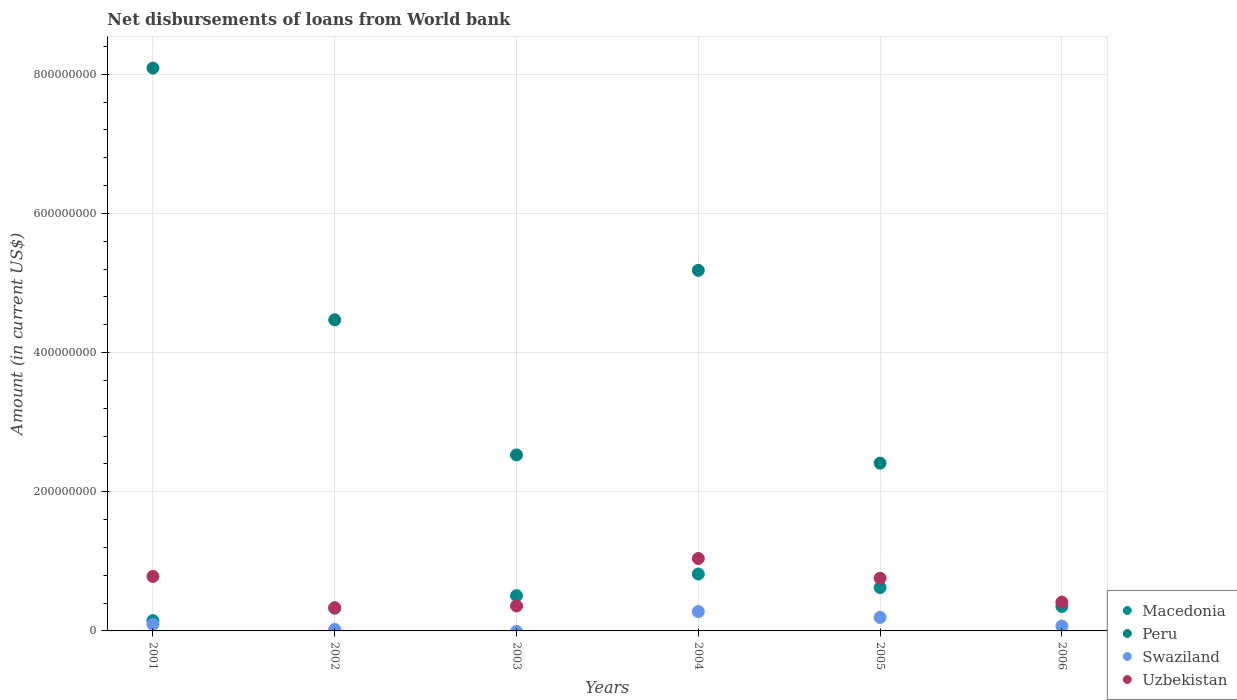How many different coloured dotlines are there?
Your answer should be very brief. 4. Is the number of dotlines equal to the number of legend labels?
Keep it short and to the point. No. What is the amount of loan disbursed from World Bank in Swaziland in 2005?
Give a very brief answer. 1.94e+07. Across all years, what is the maximum amount of loan disbursed from World Bank in Swaziland?
Ensure brevity in your answer.  2.78e+07. Across all years, what is the minimum amount of loan disbursed from World Bank in Uzbekistan?
Keep it short and to the point. 3.34e+07. What is the total amount of loan disbursed from World Bank in Peru in the graph?
Make the answer very short. 2.27e+09. What is the difference between the amount of loan disbursed from World Bank in Macedonia in 2004 and that in 2005?
Your answer should be compact. 1.94e+07. What is the difference between the amount of loan disbursed from World Bank in Uzbekistan in 2005 and the amount of loan disbursed from World Bank in Macedonia in 2001?
Your answer should be very brief. 6.09e+07. What is the average amount of loan disbursed from World Bank in Peru per year?
Your answer should be very brief. 3.78e+08. In the year 2001, what is the difference between the amount of loan disbursed from World Bank in Macedonia and amount of loan disbursed from World Bank in Uzbekistan?
Your answer should be compact. -6.35e+07. In how many years, is the amount of loan disbursed from World Bank in Uzbekistan greater than 160000000 US$?
Your answer should be very brief. 0. What is the ratio of the amount of loan disbursed from World Bank in Macedonia in 2003 to that in 2004?
Provide a succinct answer. 0.62. What is the difference between the highest and the second highest amount of loan disbursed from World Bank in Macedonia?
Your answer should be compact. 1.94e+07. What is the difference between the highest and the lowest amount of loan disbursed from World Bank in Macedonia?
Keep it short and to the point. 6.70e+07. In how many years, is the amount of loan disbursed from World Bank in Swaziland greater than the average amount of loan disbursed from World Bank in Swaziland taken over all years?
Your answer should be very brief. 2. Is the sum of the amount of loan disbursed from World Bank in Peru in 2001 and 2002 greater than the maximum amount of loan disbursed from World Bank in Macedonia across all years?
Provide a short and direct response. Yes. Is the amount of loan disbursed from World Bank in Macedonia strictly greater than the amount of loan disbursed from World Bank in Peru over the years?
Your answer should be compact. No. How many dotlines are there?
Keep it short and to the point. 4. How many years are there in the graph?
Your answer should be compact. 6. Does the graph contain any zero values?
Your answer should be very brief. Yes. Does the graph contain grids?
Ensure brevity in your answer.  Yes. Where does the legend appear in the graph?
Give a very brief answer. Bottom right. How many legend labels are there?
Provide a short and direct response. 4. How are the legend labels stacked?
Your answer should be very brief. Vertical. What is the title of the graph?
Provide a succinct answer. Net disbursements of loans from World bank. Does "Argentina" appear as one of the legend labels in the graph?
Your answer should be compact. No. What is the label or title of the X-axis?
Your answer should be very brief. Years. What is the label or title of the Y-axis?
Provide a succinct answer. Amount (in current US$). What is the Amount (in current US$) in Macedonia in 2001?
Keep it short and to the point. 1.48e+07. What is the Amount (in current US$) in Peru in 2001?
Give a very brief answer. 8.09e+08. What is the Amount (in current US$) in Swaziland in 2001?
Your answer should be very brief. 9.49e+06. What is the Amount (in current US$) of Uzbekistan in 2001?
Make the answer very short. 7.83e+07. What is the Amount (in current US$) of Macedonia in 2002?
Make the answer very short. 3.26e+07. What is the Amount (in current US$) in Peru in 2002?
Your response must be concise. 4.47e+08. What is the Amount (in current US$) in Swaziland in 2002?
Your answer should be compact. 2.17e+06. What is the Amount (in current US$) in Uzbekistan in 2002?
Your answer should be very brief. 3.34e+07. What is the Amount (in current US$) of Macedonia in 2003?
Ensure brevity in your answer.  5.07e+07. What is the Amount (in current US$) of Peru in 2003?
Give a very brief answer. 2.53e+08. What is the Amount (in current US$) of Uzbekistan in 2003?
Provide a short and direct response. 3.59e+07. What is the Amount (in current US$) in Macedonia in 2004?
Offer a very short reply. 8.18e+07. What is the Amount (in current US$) in Peru in 2004?
Provide a short and direct response. 5.18e+08. What is the Amount (in current US$) in Swaziland in 2004?
Your answer should be very brief. 2.78e+07. What is the Amount (in current US$) in Uzbekistan in 2004?
Provide a short and direct response. 1.04e+08. What is the Amount (in current US$) of Macedonia in 2005?
Your answer should be compact. 6.23e+07. What is the Amount (in current US$) in Peru in 2005?
Make the answer very short. 2.41e+08. What is the Amount (in current US$) of Swaziland in 2005?
Offer a terse response. 1.94e+07. What is the Amount (in current US$) of Uzbekistan in 2005?
Offer a very short reply. 7.57e+07. What is the Amount (in current US$) of Macedonia in 2006?
Offer a very short reply. 3.51e+07. What is the Amount (in current US$) in Swaziland in 2006?
Provide a short and direct response. 7.05e+06. What is the Amount (in current US$) in Uzbekistan in 2006?
Your answer should be compact. 4.14e+07. Across all years, what is the maximum Amount (in current US$) in Macedonia?
Provide a succinct answer. 8.18e+07. Across all years, what is the maximum Amount (in current US$) of Peru?
Offer a terse response. 8.09e+08. Across all years, what is the maximum Amount (in current US$) in Swaziland?
Make the answer very short. 2.78e+07. Across all years, what is the maximum Amount (in current US$) of Uzbekistan?
Make the answer very short. 1.04e+08. Across all years, what is the minimum Amount (in current US$) in Macedonia?
Provide a succinct answer. 1.48e+07. Across all years, what is the minimum Amount (in current US$) in Swaziland?
Offer a very short reply. 0. Across all years, what is the minimum Amount (in current US$) in Uzbekistan?
Ensure brevity in your answer.  3.34e+07. What is the total Amount (in current US$) in Macedonia in the graph?
Provide a succinct answer. 2.77e+08. What is the total Amount (in current US$) of Peru in the graph?
Your answer should be compact. 2.27e+09. What is the total Amount (in current US$) in Swaziland in the graph?
Your answer should be very brief. 6.59e+07. What is the total Amount (in current US$) in Uzbekistan in the graph?
Your answer should be very brief. 3.69e+08. What is the difference between the Amount (in current US$) of Macedonia in 2001 and that in 2002?
Offer a terse response. -1.78e+07. What is the difference between the Amount (in current US$) in Peru in 2001 and that in 2002?
Ensure brevity in your answer.  3.62e+08. What is the difference between the Amount (in current US$) in Swaziland in 2001 and that in 2002?
Make the answer very short. 7.32e+06. What is the difference between the Amount (in current US$) of Uzbekistan in 2001 and that in 2002?
Ensure brevity in your answer.  4.49e+07. What is the difference between the Amount (in current US$) of Macedonia in 2001 and that in 2003?
Provide a short and direct response. -3.60e+07. What is the difference between the Amount (in current US$) of Peru in 2001 and that in 2003?
Your answer should be very brief. 5.56e+08. What is the difference between the Amount (in current US$) of Uzbekistan in 2001 and that in 2003?
Your answer should be very brief. 4.24e+07. What is the difference between the Amount (in current US$) in Macedonia in 2001 and that in 2004?
Your response must be concise. -6.70e+07. What is the difference between the Amount (in current US$) of Peru in 2001 and that in 2004?
Provide a short and direct response. 2.91e+08. What is the difference between the Amount (in current US$) of Swaziland in 2001 and that in 2004?
Provide a short and direct response. -1.83e+07. What is the difference between the Amount (in current US$) of Uzbekistan in 2001 and that in 2004?
Keep it short and to the point. -2.58e+07. What is the difference between the Amount (in current US$) of Macedonia in 2001 and that in 2005?
Provide a short and direct response. -4.75e+07. What is the difference between the Amount (in current US$) of Peru in 2001 and that in 2005?
Your answer should be compact. 5.68e+08. What is the difference between the Amount (in current US$) of Swaziland in 2001 and that in 2005?
Your answer should be compact. -9.90e+06. What is the difference between the Amount (in current US$) in Uzbekistan in 2001 and that in 2005?
Make the answer very short. 2.62e+06. What is the difference between the Amount (in current US$) in Macedonia in 2001 and that in 2006?
Your answer should be very brief. -2.03e+07. What is the difference between the Amount (in current US$) of Swaziland in 2001 and that in 2006?
Provide a short and direct response. 2.45e+06. What is the difference between the Amount (in current US$) in Uzbekistan in 2001 and that in 2006?
Your response must be concise. 3.69e+07. What is the difference between the Amount (in current US$) in Macedonia in 2002 and that in 2003?
Make the answer very short. -1.82e+07. What is the difference between the Amount (in current US$) of Peru in 2002 and that in 2003?
Keep it short and to the point. 1.94e+08. What is the difference between the Amount (in current US$) of Uzbekistan in 2002 and that in 2003?
Give a very brief answer. -2.46e+06. What is the difference between the Amount (in current US$) in Macedonia in 2002 and that in 2004?
Your answer should be very brief. -4.92e+07. What is the difference between the Amount (in current US$) of Peru in 2002 and that in 2004?
Ensure brevity in your answer.  -7.11e+07. What is the difference between the Amount (in current US$) in Swaziland in 2002 and that in 2004?
Provide a short and direct response. -2.56e+07. What is the difference between the Amount (in current US$) of Uzbekistan in 2002 and that in 2004?
Keep it short and to the point. -7.07e+07. What is the difference between the Amount (in current US$) of Macedonia in 2002 and that in 2005?
Keep it short and to the point. -2.97e+07. What is the difference between the Amount (in current US$) of Peru in 2002 and that in 2005?
Your response must be concise. 2.06e+08. What is the difference between the Amount (in current US$) in Swaziland in 2002 and that in 2005?
Offer a terse response. -1.72e+07. What is the difference between the Amount (in current US$) of Uzbekistan in 2002 and that in 2005?
Make the answer very short. -4.23e+07. What is the difference between the Amount (in current US$) in Macedonia in 2002 and that in 2006?
Your response must be concise. -2.47e+06. What is the difference between the Amount (in current US$) of Swaziland in 2002 and that in 2006?
Ensure brevity in your answer.  -4.88e+06. What is the difference between the Amount (in current US$) in Uzbekistan in 2002 and that in 2006?
Offer a very short reply. -7.96e+06. What is the difference between the Amount (in current US$) in Macedonia in 2003 and that in 2004?
Give a very brief answer. -3.10e+07. What is the difference between the Amount (in current US$) of Peru in 2003 and that in 2004?
Offer a terse response. -2.65e+08. What is the difference between the Amount (in current US$) of Uzbekistan in 2003 and that in 2004?
Your answer should be compact. -6.82e+07. What is the difference between the Amount (in current US$) of Macedonia in 2003 and that in 2005?
Your answer should be very brief. -1.16e+07. What is the difference between the Amount (in current US$) of Peru in 2003 and that in 2005?
Your response must be concise. 1.18e+07. What is the difference between the Amount (in current US$) in Uzbekistan in 2003 and that in 2005?
Provide a succinct answer. -3.98e+07. What is the difference between the Amount (in current US$) of Macedonia in 2003 and that in 2006?
Provide a short and direct response. 1.57e+07. What is the difference between the Amount (in current US$) in Uzbekistan in 2003 and that in 2006?
Provide a short and direct response. -5.50e+06. What is the difference between the Amount (in current US$) in Macedonia in 2004 and that in 2005?
Provide a succinct answer. 1.94e+07. What is the difference between the Amount (in current US$) of Peru in 2004 and that in 2005?
Keep it short and to the point. 2.77e+08. What is the difference between the Amount (in current US$) in Swaziland in 2004 and that in 2005?
Offer a very short reply. 8.42e+06. What is the difference between the Amount (in current US$) of Uzbekistan in 2004 and that in 2005?
Give a very brief answer. 2.84e+07. What is the difference between the Amount (in current US$) in Macedonia in 2004 and that in 2006?
Give a very brief answer. 4.67e+07. What is the difference between the Amount (in current US$) of Swaziland in 2004 and that in 2006?
Keep it short and to the point. 2.08e+07. What is the difference between the Amount (in current US$) of Uzbekistan in 2004 and that in 2006?
Your answer should be very brief. 6.27e+07. What is the difference between the Amount (in current US$) in Macedonia in 2005 and that in 2006?
Ensure brevity in your answer.  2.72e+07. What is the difference between the Amount (in current US$) of Swaziland in 2005 and that in 2006?
Offer a terse response. 1.24e+07. What is the difference between the Amount (in current US$) of Uzbekistan in 2005 and that in 2006?
Your answer should be compact. 3.43e+07. What is the difference between the Amount (in current US$) of Macedonia in 2001 and the Amount (in current US$) of Peru in 2002?
Provide a short and direct response. -4.32e+08. What is the difference between the Amount (in current US$) of Macedonia in 2001 and the Amount (in current US$) of Swaziland in 2002?
Make the answer very short. 1.26e+07. What is the difference between the Amount (in current US$) of Macedonia in 2001 and the Amount (in current US$) of Uzbekistan in 2002?
Give a very brief answer. -1.86e+07. What is the difference between the Amount (in current US$) of Peru in 2001 and the Amount (in current US$) of Swaziland in 2002?
Offer a very short reply. 8.07e+08. What is the difference between the Amount (in current US$) of Peru in 2001 and the Amount (in current US$) of Uzbekistan in 2002?
Offer a terse response. 7.76e+08. What is the difference between the Amount (in current US$) of Swaziland in 2001 and the Amount (in current US$) of Uzbekistan in 2002?
Make the answer very short. -2.39e+07. What is the difference between the Amount (in current US$) of Macedonia in 2001 and the Amount (in current US$) of Peru in 2003?
Offer a terse response. -2.38e+08. What is the difference between the Amount (in current US$) of Macedonia in 2001 and the Amount (in current US$) of Uzbekistan in 2003?
Provide a succinct answer. -2.11e+07. What is the difference between the Amount (in current US$) in Peru in 2001 and the Amount (in current US$) in Uzbekistan in 2003?
Make the answer very short. 7.73e+08. What is the difference between the Amount (in current US$) of Swaziland in 2001 and the Amount (in current US$) of Uzbekistan in 2003?
Provide a short and direct response. -2.64e+07. What is the difference between the Amount (in current US$) in Macedonia in 2001 and the Amount (in current US$) in Peru in 2004?
Provide a short and direct response. -5.03e+08. What is the difference between the Amount (in current US$) in Macedonia in 2001 and the Amount (in current US$) in Swaziland in 2004?
Provide a succinct answer. -1.30e+07. What is the difference between the Amount (in current US$) in Macedonia in 2001 and the Amount (in current US$) in Uzbekistan in 2004?
Offer a terse response. -8.93e+07. What is the difference between the Amount (in current US$) of Peru in 2001 and the Amount (in current US$) of Swaziland in 2004?
Offer a terse response. 7.81e+08. What is the difference between the Amount (in current US$) in Peru in 2001 and the Amount (in current US$) in Uzbekistan in 2004?
Ensure brevity in your answer.  7.05e+08. What is the difference between the Amount (in current US$) of Swaziland in 2001 and the Amount (in current US$) of Uzbekistan in 2004?
Provide a short and direct response. -9.46e+07. What is the difference between the Amount (in current US$) in Macedonia in 2001 and the Amount (in current US$) in Peru in 2005?
Your response must be concise. -2.26e+08. What is the difference between the Amount (in current US$) in Macedonia in 2001 and the Amount (in current US$) in Swaziland in 2005?
Offer a terse response. -4.63e+06. What is the difference between the Amount (in current US$) in Macedonia in 2001 and the Amount (in current US$) in Uzbekistan in 2005?
Your answer should be very brief. -6.09e+07. What is the difference between the Amount (in current US$) of Peru in 2001 and the Amount (in current US$) of Swaziland in 2005?
Your answer should be very brief. 7.90e+08. What is the difference between the Amount (in current US$) in Peru in 2001 and the Amount (in current US$) in Uzbekistan in 2005?
Provide a succinct answer. 7.33e+08. What is the difference between the Amount (in current US$) of Swaziland in 2001 and the Amount (in current US$) of Uzbekistan in 2005?
Your response must be concise. -6.62e+07. What is the difference between the Amount (in current US$) in Macedonia in 2001 and the Amount (in current US$) in Swaziland in 2006?
Offer a very short reply. 7.72e+06. What is the difference between the Amount (in current US$) in Macedonia in 2001 and the Amount (in current US$) in Uzbekistan in 2006?
Ensure brevity in your answer.  -2.66e+07. What is the difference between the Amount (in current US$) of Peru in 2001 and the Amount (in current US$) of Swaziland in 2006?
Give a very brief answer. 8.02e+08. What is the difference between the Amount (in current US$) in Peru in 2001 and the Amount (in current US$) in Uzbekistan in 2006?
Your response must be concise. 7.68e+08. What is the difference between the Amount (in current US$) in Swaziland in 2001 and the Amount (in current US$) in Uzbekistan in 2006?
Offer a very short reply. -3.19e+07. What is the difference between the Amount (in current US$) in Macedonia in 2002 and the Amount (in current US$) in Peru in 2003?
Make the answer very short. -2.20e+08. What is the difference between the Amount (in current US$) in Macedonia in 2002 and the Amount (in current US$) in Uzbekistan in 2003?
Your answer should be compact. -3.28e+06. What is the difference between the Amount (in current US$) in Peru in 2002 and the Amount (in current US$) in Uzbekistan in 2003?
Offer a very short reply. 4.11e+08. What is the difference between the Amount (in current US$) in Swaziland in 2002 and the Amount (in current US$) in Uzbekistan in 2003?
Provide a short and direct response. -3.37e+07. What is the difference between the Amount (in current US$) of Macedonia in 2002 and the Amount (in current US$) of Peru in 2004?
Make the answer very short. -4.86e+08. What is the difference between the Amount (in current US$) in Macedonia in 2002 and the Amount (in current US$) in Swaziland in 2004?
Your answer should be compact. 4.77e+06. What is the difference between the Amount (in current US$) of Macedonia in 2002 and the Amount (in current US$) of Uzbekistan in 2004?
Offer a very short reply. -7.15e+07. What is the difference between the Amount (in current US$) of Peru in 2002 and the Amount (in current US$) of Swaziland in 2004?
Provide a short and direct response. 4.19e+08. What is the difference between the Amount (in current US$) in Peru in 2002 and the Amount (in current US$) in Uzbekistan in 2004?
Make the answer very short. 3.43e+08. What is the difference between the Amount (in current US$) in Swaziland in 2002 and the Amount (in current US$) in Uzbekistan in 2004?
Keep it short and to the point. -1.02e+08. What is the difference between the Amount (in current US$) of Macedonia in 2002 and the Amount (in current US$) of Peru in 2005?
Provide a short and direct response. -2.09e+08. What is the difference between the Amount (in current US$) in Macedonia in 2002 and the Amount (in current US$) in Swaziland in 2005?
Ensure brevity in your answer.  1.32e+07. What is the difference between the Amount (in current US$) in Macedonia in 2002 and the Amount (in current US$) in Uzbekistan in 2005?
Your answer should be compact. -4.31e+07. What is the difference between the Amount (in current US$) of Peru in 2002 and the Amount (in current US$) of Swaziland in 2005?
Provide a succinct answer. 4.28e+08. What is the difference between the Amount (in current US$) of Peru in 2002 and the Amount (in current US$) of Uzbekistan in 2005?
Your response must be concise. 3.71e+08. What is the difference between the Amount (in current US$) in Swaziland in 2002 and the Amount (in current US$) in Uzbekistan in 2005?
Make the answer very short. -7.35e+07. What is the difference between the Amount (in current US$) of Macedonia in 2002 and the Amount (in current US$) of Swaziland in 2006?
Keep it short and to the point. 2.55e+07. What is the difference between the Amount (in current US$) of Macedonia in 2002 and the Amount (in current US$) of Uzbekistan in 2006?
Provide a short and direct response. -8.78e+06. What is the difference between the Amount (in current US$) in Peru in 2002 and the Amount (in current US$) in Swaziland in 2006?
Keep it short and to the point. 4.40e+08. What is the difference between the Amount (in current US$) in Peru in 2002 and the Amount (in current US$) in Uzbekistan in 2006?
Keep it short and to the point. 4.06e+08. What is the difference between the Amount (in current US$) of Swaziland in 2002 and the Amount (in current US$) of Uzbekistan in 2006?
Offer a terse response. -3.92e+07. What is the difference between the Amount (in current US$) of Macedonia in 2003 and the Amount (in current US$) of Peru in 2004?
Give a very brief answer. -4.67e+08. What is the difference between the Amount (in current US$) in Macedonia in 2003 and the Amount (in current US$) in Swaziland in 2004?
Provide a succinct answer. 2.29e+07. What is the difference between the Amount (in current US$) of Macedonia in 2003 and the Amount (in current US$) of Uzbekistan in 2004?
Provide a short and direct response. -5.34e+07. What is the difference between the Amount (in current US$) in Peru in 2003 and the Amount (in current US$) in Swaziland in 2004?
Give a very brief answer. 2.25e+08. What is the difference between the Amount (in current US$) in Peru in 2003 and the Amount (in current US$) in Uzbekistan in 2004?
Your answer should be compact. 1.49e+08. What is the difference between the Amount (in current US$) in Macedonia in 2003 and the Amount (in current US$) in Peru in 2005?
Keep it short and to the point. -1.90e+08. What is the difference between the Amount (in current US$) of Macedonia in 2003 and the Amount (in current US$) of Swaziland in 2005?
Provide a short and direct response. 3.13e+07. What is the difference between the Amount (in current US$) in Macedonia in 2003 and the Amount (in current US$) in Uzbekistan in 2005?
Provide a short and direct response. -2.50e+07. What is the difference between the Amount (in current US$) of Peru in 2003 and the Amount (in current US$) of Swaziland in 2005?
Your answer should be compact. 2.34e+08. What is the difference between the Amount (in current US$) of Peru in 2003 and the Amount (in current US$) of Uzbekistan in 2005?
Give a very brief answer. 1.77e+08. What is the difference between the Amount (in current US$) of Macedonia in 2003 and the Amount (in current US$) of Swaziland in 2006?
Give a very brief answer. 4.37e+07. What is the difference between the Amount (in current US$) in Macedonia in 2003 and the Amount (in current US$) in Uzbekistan in 2006?
Provide a succinct answer. 9.38e+06. What is the difference between the Amount (in current US$) of Peru in 2003 and the Amount (in current US$) of Swaziland in 2006?
Your answer should be very brief. 2.46e+08. What is the difference between the Amount (in current US$) of Peru in 2003 and the Amount (in current US$) of Uzbekistan in 2006?
Ensure brevity in your answer.  2.12e+08. What is the difference between the Amount (in current US$) in Macedonia in 2004 and the Amount (in current US$) in Peru in 2005?
Provide a succinct answer. -1.59e+08. What is the difference between the Amount (in current US$) of Macedonia in 2004 and the Amount (in current US$) of Swaziland in 2005?
Give a very brief answer. 6.24e+07. What is the difference between the Amount (in current US$) in Macedonia in 2004 and the Amount (in current US$) in Uzbekistan in 2005?
Provide a succinct answer. 6.05e+06. What is the difference between the Amount (in current US$) of Peru in 2004 and the Amount (in current US$) of Swaziland in 2005?
Make the answer very short. 4.99e+08. What is the difference between the Amount (in current US$) of Peru in 2004 and the Amount (in current US$) of Uzbekistan in 2005?
Your answer should be very brief. 4.42e+08. What is the difference between the Amount (in current US$) in Swaziland in 2004 and the Amount (in current US$) in Uzbekistan in 2005?
Keep it short and to the point. -4.79e+07. What is the difference between the Amount (in current US$) in Macedonia in 2004 and the Amount (in current US$) in Swaziland in 2006?
Your answer should be very brief. 7.47e+07. What is the difference between the Amount (in current US$) of Macedonia in 2004 and the Amount (in current US$) of Uzbekistan in 2006?
Your response must be concise. 4.04e+07. What is the difference between the Amount (in current US$) of Peru in 2004 and the Amount (in current US$) of Swaziland in 2006?
Give a very brief answer. 5.11e+08. What is the difference between the Amount (in current US$) in Peru in 2004 and the Amount (in current US$) in Uzbekistan in 2006?
Offer a very short reply. 4.77e+08. What is the difference between the Amount (in current US$) in Swaziland in 2004 and the Amount (in current US$) in Uzbekistan in 2006?
Offer a terse response. -1.35e+07. What is the difference between the Amount (in current US$) of Macedonia in 2005 and the Amount (in current US$) of Swaziland in 2006?
Your answer should be very brief. 5.53e+07. What is the difference between the Amount (in current US$) of Macedonia in 2005 and the Amount (in current US$) of Uzbekistan in 2006?
Your answer should be very brief. 2.09e+07. What is the difference between the Amount (in current US$) in Peru in 2005 and the Amount (in current US$) in Swaziland in 2006?
Your response must be concise. 2.34e+08. What is the difference between the Amount (in current US$) of Peru in 2005 and the Amount (in current US$) of Uzbekistan in 2006?
Offer a terse response. 2.00e+08. What is the difference between the Amount (in current US$) of Swaziland in 2005 and the Amount (in current US$) of Uzbekistan in 2006?
Offer a very short reply. -2.20e+07. What is the average Amount (in current US$) of Macedonia per year?
Your answer should be compact. 4.62e+07. What is the average Amount (in current US$) of Peru per year?
Ensure brevity in your answer.  3.78e+08. What is the average Amount (in current US$) in Swaziland per year?
Keep it short and to the point. 1.10e+07. What is the average Amount (in current US$) in Uzbekistan per year?
Make the answer very short. 6.15e+07. In the year 2001, what is the difference between the Amount (in current US$) of Macedonia and Amount (in current US$) of Peru?
Your answer should be very brief. -7.94e+08. In the year 2001, what is the difference between the Amount (in current US$) of Macedonia and Amount (in current US$) of Swaziland?
Give a very brief answer. 5.28e+06. In the year 2001, what is the difference between the Amount (in current US$) of Macedonia and Amount (in current US$) of Uzbekistan?
Your answer should be compact. -6.35e+07. In the year 2001, what is the difference between the Amount (in current US$) in Peru and Amount (in current US$) in Swaziland?
Provide a short and direct response. 7.99e+08. In the year 2001, what is the difference between the Amount (in current US$) of Peru and Amount (in current US$) of Uzbekistan?
Keep it short and to the point. 7.31e+08. In the year 2001, what is the difference between the Amount (in current US$) in Swaziland and Amount (in current US$) in Uzbekistan?
Make the answer very short. -6.88e+07. In the year 2002, what is the difference between the Amount (in current US$) of Macedonia and Amount (in current US$) of Peru?
Keep it short and to the point. -4.15e+08. In the year 2002, what is the difference between the Amount (in current US$) in Macedonia and Amount (in current US$) in Swaziland?
Your answer should be compact. 3.04e+07. In the year 2002, what is the difference between the Amount (in current US$) in Macedonia and Amount (in current US$) in Uzbekistan?
Your answer should be compact. -8.17e+05. In the year 2002, what is the difference between the Amount (in current US$) in Peru and Amount (in current US$) in Swaziland?
Keep it short and to the point. 4.45e+08. In the year 2002, what is the difference between the Amount (in current US$) of Peru and Amount (in current US$) of Uzbekistan?
Ensure brevity in your answer.  4.14e+08. In the year 2002, what is the difference between the Amount (in current US$) of Swaziland and Amount (in current US$) of Uzbekistan?
Your answer should be very brief. -3.12e+07. In the year 2003, what is the difference between the Amount (in current US$) in Macedonia and Amount (in current US$) in Peru?
Offer a very short reply. -2.02e+08. In the year 2003, what is the difference between the Amount (in current US$) of Macedonia and Amount (in current US$) of Uzbekistan?
Make the answer very short. 1.49e+07. In the year 2003, what is the difference between the Amount (in current US$) of Peru and Amount (in current US$) of Uzbekistan?
Ensure brevity in your answer.  2.17e+08. In the year 2004, what is the difference between the Amount (in current US$) of Macedonia and Amount (in current US$) of Peru?
Provide a succinct answer. -4.36e+08. In the year 2004, what is the difference between the Amount (in current US$) of Macedonia and Amount (in current US$) of Swaziland?
Give a very brief answer. 5.39e+07. In the year 2004, what is the difference between the Amount (in current US$) in Macedonia and Amount (in current US$) in Uzbekistan?
Provide a succinct answer. -2.24e+07. In the year 2004, what is the difference between the Amount (in current US$) of Peru and Amount (in current US$) of Swaziland?
Make the answer very short. 4.90e+08. In the year 2004, what is the difference between the Amount (in current US$) in Peru and Amount (in current US$) in Uzbekistan?
Provide a short and direct response. 4.14e+08. In the year 2004, what is the difference between the Amount (in current US$) of Swaziland and Amount (in current US$) of Uzbekistan?
Offer a terse response. -7.63e+07. In the year 2005, what is the difference between the Amount (in current US$) of Macedonia and Amount (in current US$) of Peru?
Offer a terse response. -1.79e+08. In the year 2005, what is the difference between the Amount (in current US$) of Macedonia and Amount (in current US$) of Swaziland?
Your answer should be compact. 4.29e+07. In the year 2005, what is the difference between the Amount (in current US$) of Macedonia and Amount (in current US$) of Uzbekistan?
Provide a succinct answer. -1.34e+07. In the year 2005, what is the difference between the Amount (in current US$) in Peru and Amount (in current US$) in Swaziland?
Give a very brief answer. 2.22e+08. In the year 2005, what is the difference between the Amount (in current US$) in Peru and Amount (in current US$) in Uzbekistan?
Ensure brevity in your answer.  1.65e+08. In the year 2005, what is the difference between the Amount (in current US$) in Swaziland and Amount (in current US$) in Uzbekistan?
Keep it short and to the point. -5.63e+07. In the year 2006, what is the difference between the Amount (in current US$) of Macedonia and Amount (in current US$) of Swaziland?
Offer a terse response. 2.80e+07. In the year 2006, what is the difference between the Amount (in current US$) of Macedonia and Amount (in current US$) of Uzbekistan?
Your answer should be very brief. -6.31e+06. In the year 2006, what is the difference between the Amount (in current US$) of Swaziland and Amount (in current US$) of Uzbekistan?
Your response must be concise. -3.43e+07. What is the ratio of the Amount (in current US$) of Macedonia in 2001 to that in 2002?
Ensure brevity in your answer.  0.45. What is the ratio of the Amount (in current US$) of Peru in 2001 to that in 2002?
Your answer should be compact. 1.81. What is the ratio of the Amount (in current US$) in Swaziland in 2001 to that in 2002?
Your response must be concise. 4.37. What is the ratio of the Amount (in current US$) in Uzbekistan in 2001 to that in 2002?
Make the answer very short. 2.34. What is the ratio of the Amount (in current US$) of Macedonia in 2001 to that in 2003?
Offer a very short reply. 0.29. What is the ratio of the Amount (in current US$) of Peru in 2001 to that in 2003?
Your answer should be compact. 3.2. What is the ratio of the Amount (in current US$) in Uzbekistan in 2001 to that in 2003?
Your answer should be compact. 2.18. What is the ratio of the Amount (in current US$) in Macedonia in 2001 to that in 2004?
Make the answer very short. 0.18. What is the ratio of the Amount (in current US$) in Peru in 2001 to that in 2004?
Offer a terse response. 1.56. What is the ratio of the Amount (in current US$) of Swaziland in 2001 to that in 2004?
Give a very brief answer. 0.34. What is the ratio of the Amount (in current US$) in Uzbekistan in 2001 to that in 2004?
Offer a terse response. 0.75. What is the ratio of the Amount (in current US$) of Macedonia in 2001 to that in 2005?
Provide a succinct answer. 0.24. What is the ratio of the Amount (in current US$) of Peru in 2001 to that in 2005?
Provide a short and direct response. 3.35. What is the ratio of the Amount (in current US$) in Swaziland in 2001 to that in 2005?
Offer a very short reply. 0.49. What is the ratio of the Amount (in current US$) in Uzbekistan in 2001 to that in 2005?
Offer a terse response. 1.03. What is the ratio of the Amount (in current US$) of Macedonia in 2001 to that in 2006?
Provide a short and direct response. 0.42. What is the ratio of the Amount (in current US$) of Swaziland in 2001 to that in 2006?
Ensure brevity in your answer.  1.35. What is the ratio of the Amount (in current US$) of Uzbekistan in 2001 to that in 2006?
Your answer should be very brief. 1.89. What is the ratio of the Amount (in current US$) of Macedonia in 2002 to that in 2003?
Provide a short and direct response. 0.64. What is the ratio of the Amount (in current US$) of Peru in 2002 to that in 2003?
Your response must be concise. 1.77. What is the ratio of the Amount (in current US$) in Uzbekistan in 2002 to that in 2003?
Provide a succinct answer. 0.93. What is the ratio of the Amount (in current US$) of Macedonia in 2002 to that in 2004?
Provide a short and direct response. 0.4. What is the ratio of the Amount (in current US$) of Peru in 2002 to that in 2004?
Your answer should be compact. 0.86. What is the ratio of the Amount (in current US$) in Swaziland in 2002 to that in 2004?
Ensure brevity in your answer.  0.08. What is the ratio of the Amount (in current US$) of Uzbekistan in 2002 to that in 2004?
Keep it short and to the point. 0.32. What is the ratio of the Amount (in current US$) in Macedonia in 2002 to that in 2005?
Ensure brevity in your answer.  0.52. What is the ratio of the Amount (in current US$) of Peru in 2002 to that in 2005?
Keep it short and to the point. 1.85. What is the ratio of the Amount (in current US$) of Swaziland in 2002 to that in 2005?
Your answer should be compact. 0.11. What is the ratio of the Amount (in current US$) of Uzbekistan in 2002 to that in 2005?
Your response must be concise. 0.44. What is the ratio of the Amount (in current US$) in Macedonia in 2002 to that in 2006?
Your response must be concise. 0.93. What is the ratio of the Amount (in current US$) of Swaziland in 2002 to that in 2006?
Your answer should be very brief. 0.31. What is the ratio of the Amount (in current US$) of Uzbekistan in 2002 to that in 2006?
Your answer should be very brief. 0.81. What is the ratio of the Amount (in current US$) of Macedonia in 2003 to that in 2004?
Provide a short and direct response. 0.62. What is the ratio of the Amount (in current US$) in Peru in 2003 to that in 2004?
Your answer should be compact. 0.49. What is the ratio of the Amount (in current US$) of Uzbekistan in 2003 to that in 2004?
Offer a very short reply. 0.34. What is the ratio of the Amount (in current US$) of Macedonia in 2003 to that in 2005?
Keep it short and to the point. 0.81. What is the ratio of the Amount (in current US$) of Peru in 2003 to that in 2005?
Make the answer very short. 1.05. What is the ratio of the Amount (in current US$) of Uzbekistan in 2003 to that in 2005?
Your response must be concise. 0.47. What is the ratio of the Amount (in current US$) in Macedonia in 2003 to that in 2006?
Give a very brief answer. 1.45. What is the ratio of the Amount (in current US$) of Uzbekistan in 2003 to that in 2006?
Ensure brevity in your answer.  0.87. What is the ratio of the Amount (in current US$) of Macedonia in 2004 to that in 2005?
Ensure brevity in your answer.  1.31. What is the ratio of the Amount (in current US$) of Peru in 2004 to that in 2005?
Make the answer very short. 2.15. What is the ratio of the Amount (in current US$) of Swaziland in 2004 to that in 2005?
Provide a succinct answer. 1.43. What is the ratio of the Amount (in current US$) of Uzbekistan in 2004 to that in 2005?
Keep it short and to the point. 1.38. What is the ratio of the Amount (in current US$) of Macedonia in 2004 to that in 2006?
Provide a short and direct response. 2.33. What is the ratio of the Amount (in current US$) in Swaziland in 2004 to that in 2006?
Offer a terse response. 3.95. What is the ratio of the Amount (in current US$) in Uzbekistan in 2004 to that in 2006?
Keep it short and to the point. 2.52. What is the ratio of the Amount (in current US$) in Macedonia in 2005 to that in 2006?
Provide a succinct answer. 1.78. What is the ratio of the Amount (in current US$) in Swaziland in 2005 to that in 2006?
Your answer should be very brief. 2.75. What is the ratio of the Amount (in current US$) of Uzbekistan in 2005 to that in 2006?
Provide a succinct answer. 1.83. What is the difference between the highest and the second highest Amount (in current US$) in Macedonia?
Give a very brief answer. 1.94e+07. What is the difference between the highest and the second highest Amount (in current US$) of Peru?
Give a very brief answer. 2.91e+08. What is the difference between the highest and the second highest Amount (in current US$) in Swaziland?
Keep it short and to the point. 8.42e+06. What is the difference between the highest and the second highest Amount (in current US$) in Uzbekistan?
Offer a terse response. 2.58e+07. What is the difference between the highest and the lowest Amount (in current US$) in Macedonia?
Your response must be concise. 6.70e+07. What is the difference between the highest and the lowest Amount (in current US$) of Peru?
Give a very brief answer. 8.09e+08. What is the difference between the highest and the lowest Amount (in current US$) in Swaziland?
Make the answer very short. 2.78e+07. What is the difference between the highest and the lowest Amount (in current US$) of Uzbekistan?
Ensure brevity in your answer.  7.07e+07. 